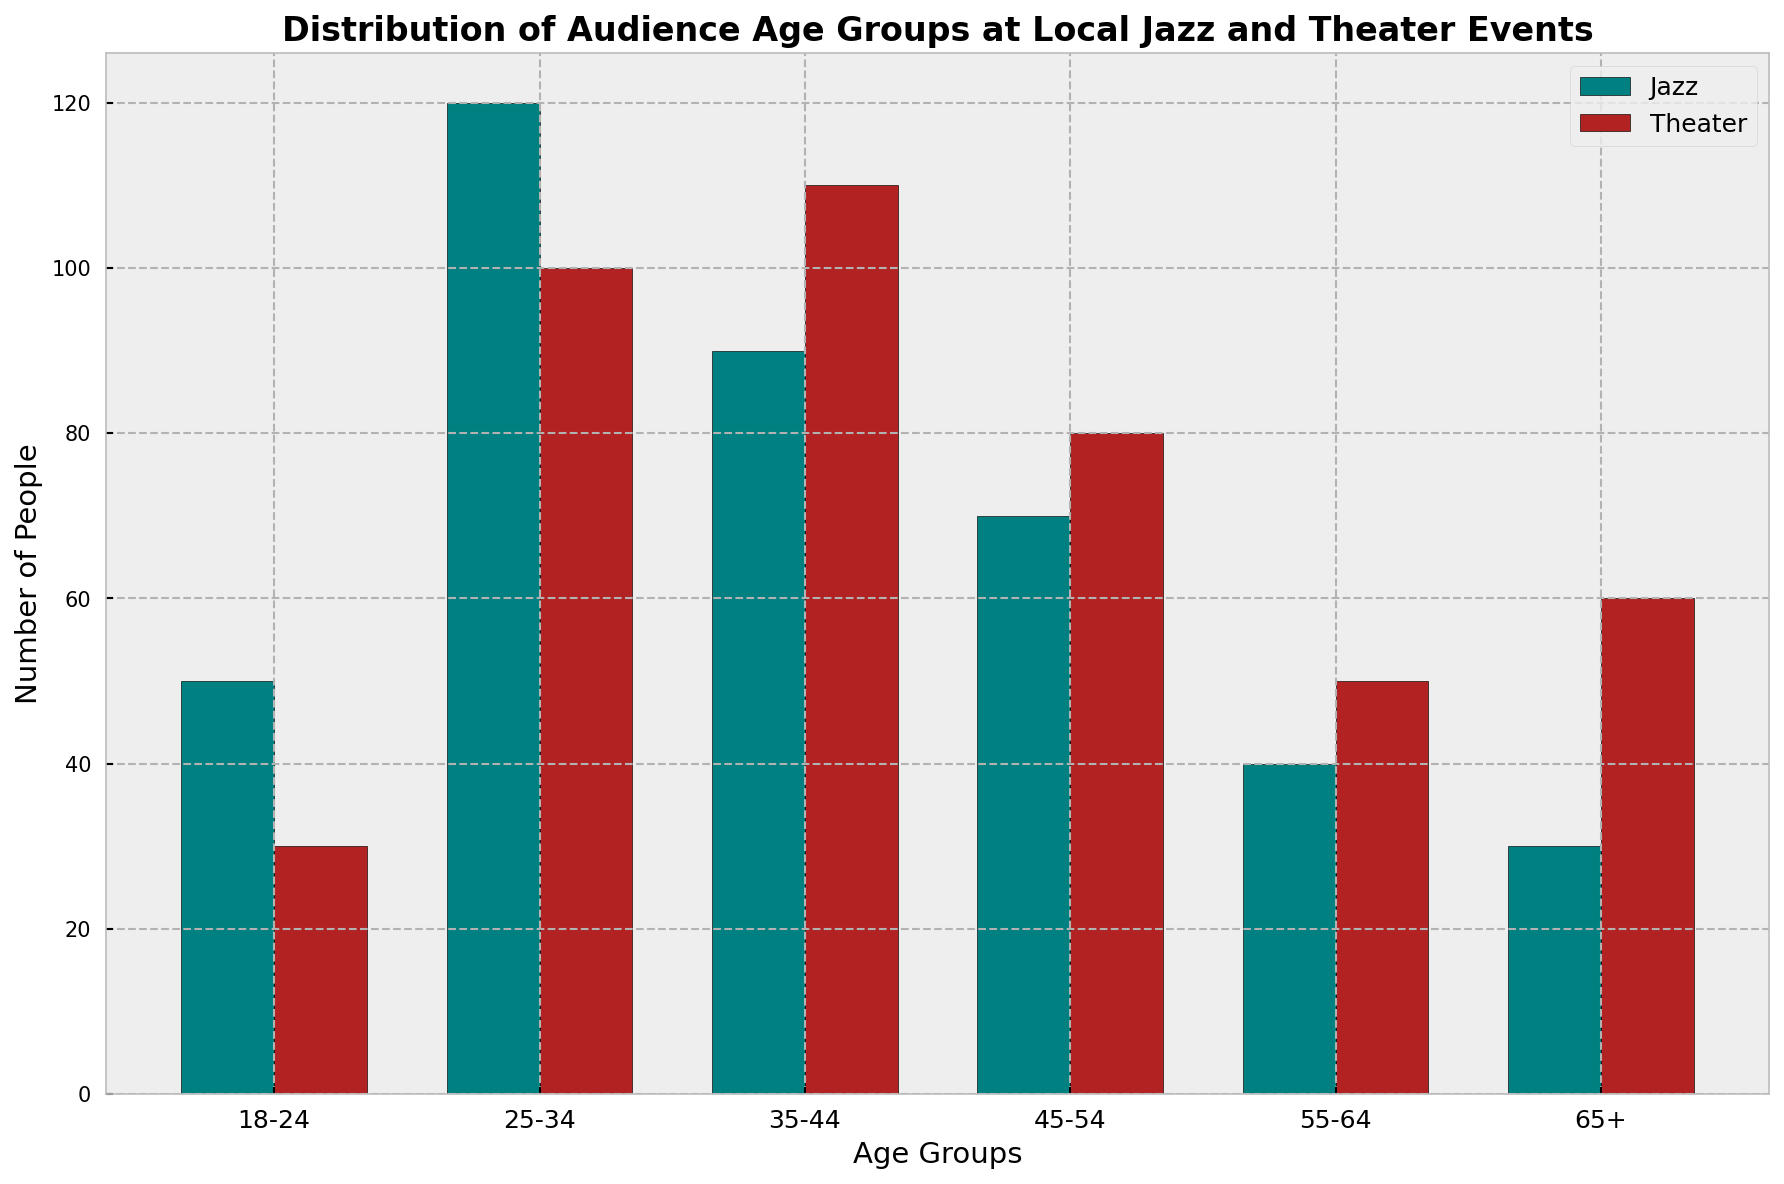What is the most populous age group for Jazz events? The height of the bars for each age group representing Jazz events shows that the bar for the age group 25-34 is the tallest.
Answer: 25-34 Which event type has a higher number of attendees in the 65+ age group? Comparing the height of the bars for the 65+ age group for both event types, the Theater bar is taller than the Jazz bar.
Answer: Theater How many more people attended Jazz events in the 35-44 age group than in the 18-24 age group? The number of attendees in the 35-44 age group for Jazz is 90, and for the 18-24 age group, it is 50. The difference is 90 - 50.
Answer: 40 For both event types combined, what is the total number of attendees in the 55-64 age group? The number of attendees in the 55-64 age group is 40 for Jazz and 50 for Theater. The total is 40 + 50.
Answer: 90 What percentage of attendees at Theater events fall in the 25-34 age group? The total number of attendees at Theater events is 30 + 100 + 110 + 80 + 50 + 60 = 430. The number in the 25-34 age group is 100, so the percentage is (100/430) * 100.
Answer: 23.26% What is the average number of attendees for Jazz events across all age groups? The total number of Jazz attendees is 50 + 120 + 90 + 70 + 40 + 30 = 400. There are 6 age groups, so the average is 400 / 6.
Answer: 66.67 